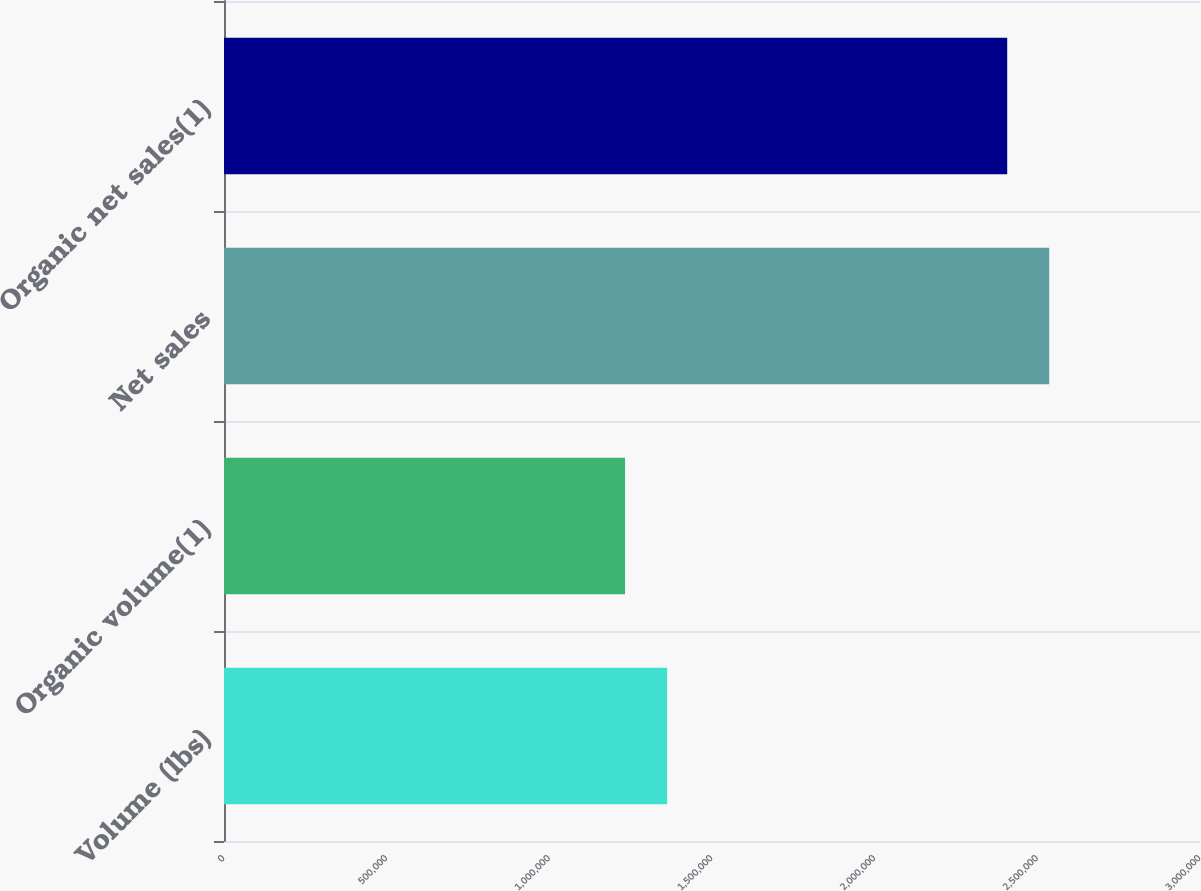Convert chart. <chart><loc_0><loc_0><loc_500><loc_500><bar_chart><fcel>Volume (lbs)<fcel>Organic volume(1)<fcel>Net sales<fcel>Organic net sales(1)<nl><fcel>1.36192e+06<fcel>1.23273e+06<fcel>2.5366e+06<fcel>2.4074e+06<nl></chart> 